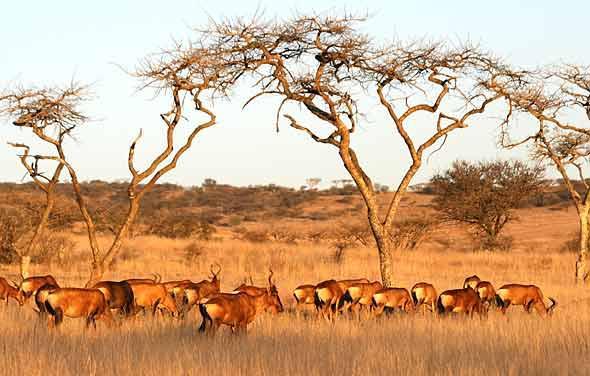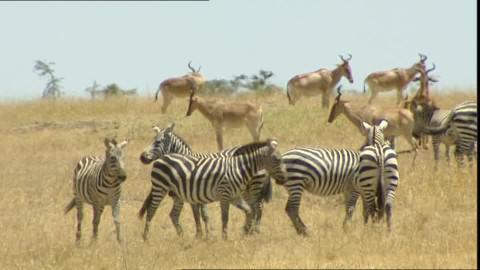The first image is the image on the left, the second image is the image on the right. Examine the images to the left and right. Is the description "Zebras are near the horned animals in the image on the right." accurate? Answer yes or no. Yes. The first image is the image on the left, the second image is the image on the right. Considering the images on both sides, is "An image includes multiple zebra and at least one brown horned animal." valid? Answer yes or no. Yes. 